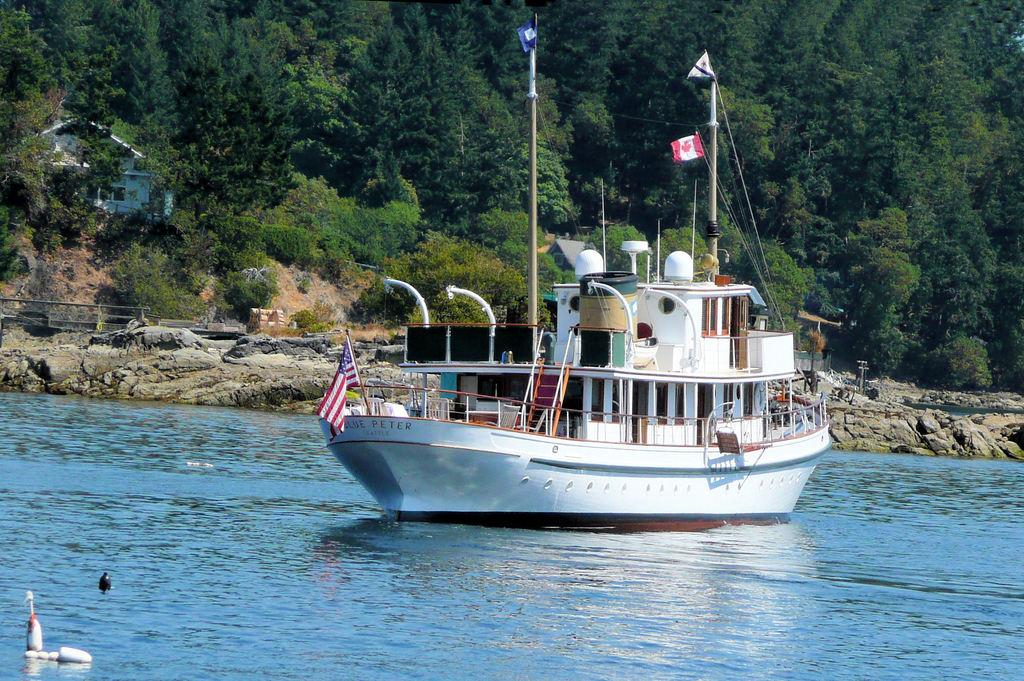Provide a one-sentence caption for the provided image. The Canadian ship has the name of Peter. 